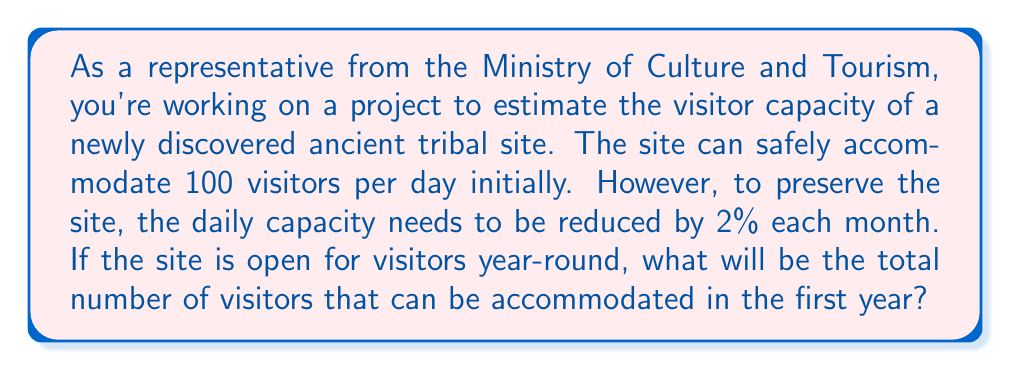Show me your answer to this math problem. Let's approach this step-by-step:

1) First, we need to calculate the monthly visitor capacity for each month.

2) The initial daily capacity is 100 visitors, so the initial monthly capacity is:
   $100 \times 30 = 3000$ visitors per month

3) Each month, the capacity reduces by 2%. This means that each month, the capacity is 98% of the previous month.

4) We can represent this as a geometric sequence with:
   $a_1 = 3000$ (first term)
   $r = 0.98$ (common ratio)
   $n = 12$ (number of terms, as we're calculating for a year)

5) The sum of a geometric sequence is given by the formula:
   $$S_n = \frac{a_1(1-r^n)}{1-r}$$
   where $S_n$ is the sum of the first $n$ terms

6) Substituting our values:
   $$S_{12} = \frac{3000(1-0.98^{12})}{1-0.98}$$

7) Calculate:
   $$S_{12} = \frac{3000(1-0.7847)}{0.02} = \frac{3000 \times 0.2153}{0.02} = 32,295$$

Therefore, the total number of visitors that can be accommodated in the first year is approximately 32,295.
Answer: 32,295 visitors 